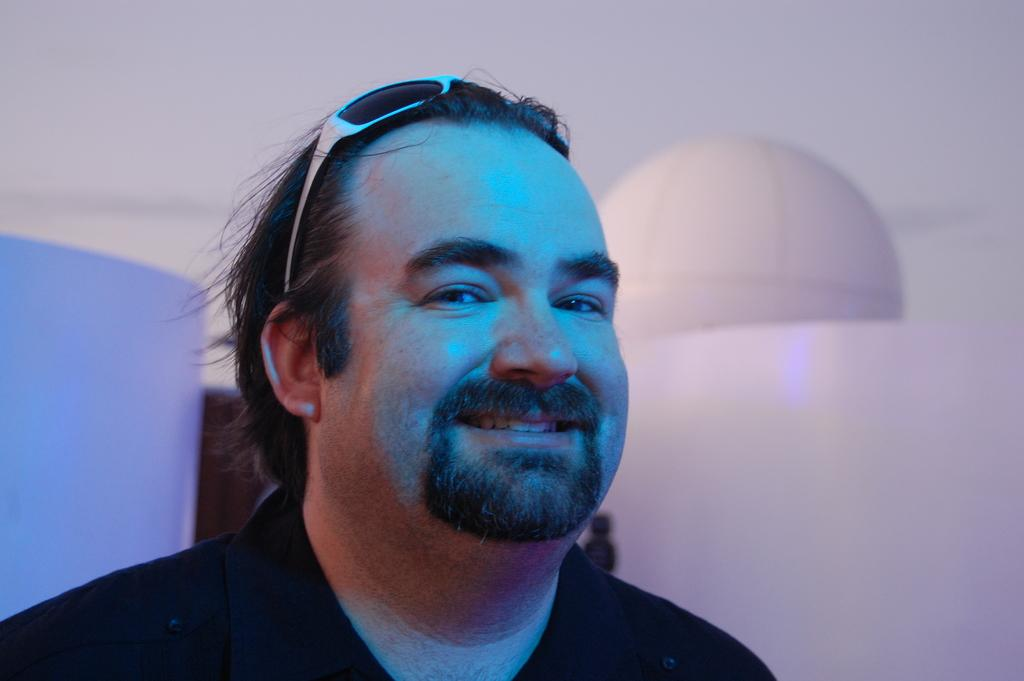What is the main subject of the image? There is a man in the image. What is the man's facial expression? The man is smiling. What can be seen in the background of the image? There is a surface visible in the background of the image. What type of meat is the man cooking in the image? There is no meat or cooking activity present in the image; it only features a man smiling. 